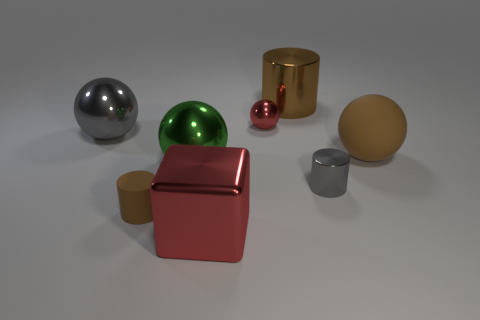Subtract all brown metal cylinders. How many cylinders are left? 2 Subtract all brown blocks. How many gray spheres are left? 1 Subtract all gray cylinders. How many cylinders are left? 2 Subtract 2 cylinders. How many cylinders are left? 1 Subtract all red balls. Subtract all red blocks. How many balls are left? 3 Subtract all tiny brown rubber spheres. Subtract all brown spheres. How many objects are left? 7 Add 4 small things. How many small things are left? 7 Add 6 large cyan cylinders. How many large cyan cylinders exist? 6 Add 2 large gray metal objects. How many objects exist? 10 Subtract 0 purple cylinders. How many objects are left? 8 